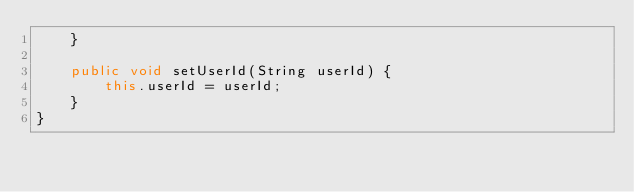<code> <loc_0><loc_0><loc_500><loc_500><_Java_>    }

    public void setUserId(String userId) {
        this.userId = userId;
    }
}
</code> 